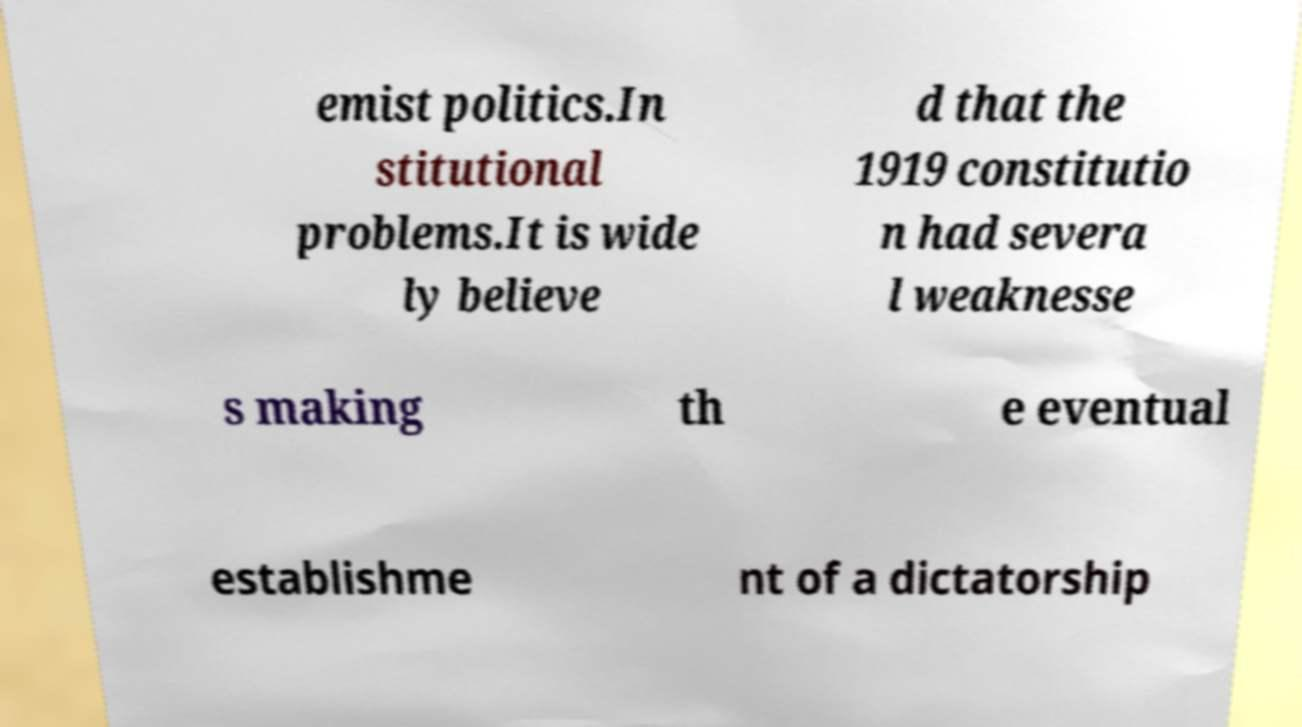Can you read and provide the text displayed in the image?This photo seems to have some interesting text. Can you extract and type it out for me? emist politics.In stitutional problems.It is wide ly believe d that the 1919 constitutio n had severa l weaknesse s making th e eventual establishme nt of a dictatorship 